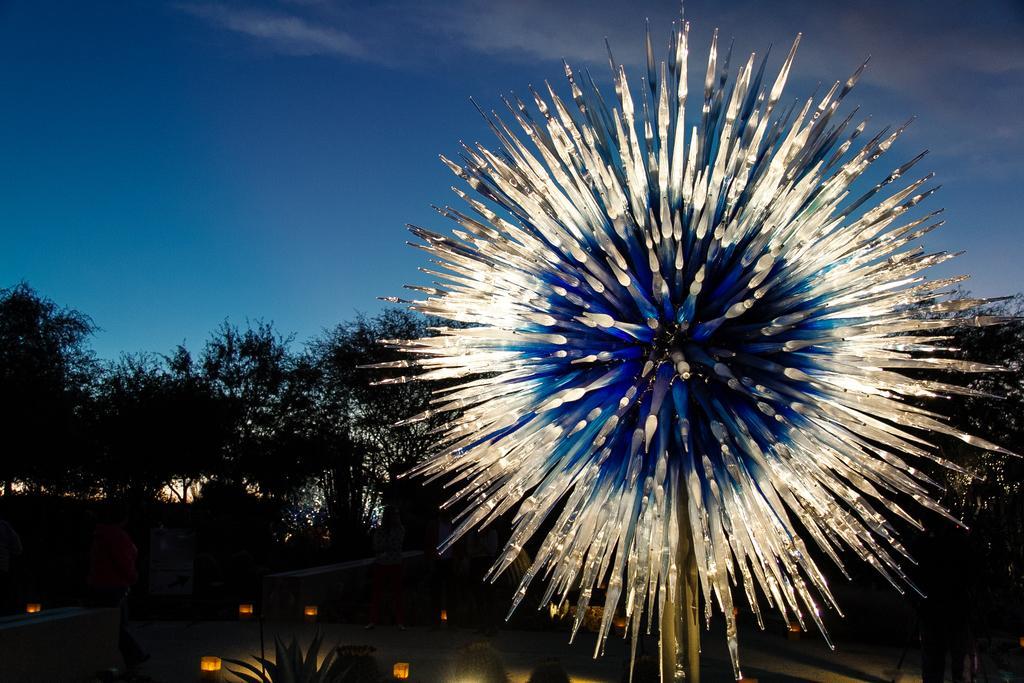Can you describe this image briefly? In this picture I can see few trees and a plant and I can see few lights and a blue cloudy sky. 